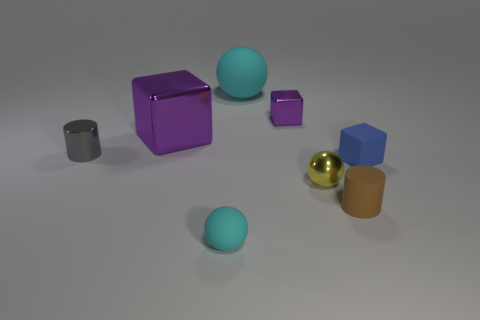What number of other shiny cubes are the same color as the tiny metallic block?
Keep it short and to the point. 1. There is a large object that is the same color as the tiny metallic cube; what is its material?
Offer a terse response. Metal. What is the material of the gray cylinder?
Offer a terse response. Metal. Do the cyan ball that is in front of the brown cylinder and the big ball have the same material?
Keep it short and to the point. Yes. The cyan object that is in front of the gray thing has what shape?
Offer a very short reply. Sphere. What is the material of the purple block that is the same size as the yellow sphere?
Offer a terse response. Metal. How many objects are either matte things left of the blue cube or tiny cylinders in front of the small gray thing?
Provide a succinct answer. 3. What size is the cube that is made of the same material as the tiny cyan object?
Keep it short and to the point. Small. What number of matte objects are either small gray cylinders or small gray cubes?
Make the answer very short. 0. What size is the shiny cylinder?
Provide a succinct answer. Small. 